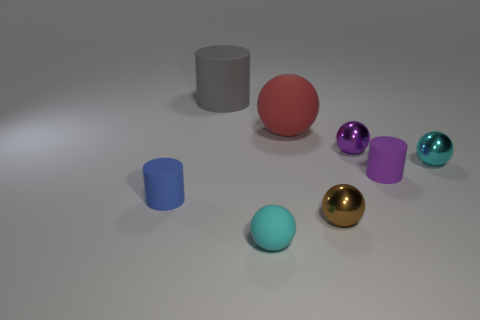Subtract 2 spheres. How many spheres are left? 3 Subtract all red spheres. How many spheres are left? 4 Subtract all small matte spheres. How many spheres are left? 4 Subtract all gray balls. Subtract all brown cylinders. How many balls are left? 5 Add 2 red balls. How many objects exist? 10 Subtract all balls. How many objects are left? 3 Add 8 tiny purple metallic things. How many tiny purple metallic things exist? 9 Subtract 0 yellow cylinders. How many objects are left? 8 Subtract all large green cubes. Subtract all big red rubber things. How many objects are left? 7 Add 1 brown spheres. How many brown spheres are left? 2 